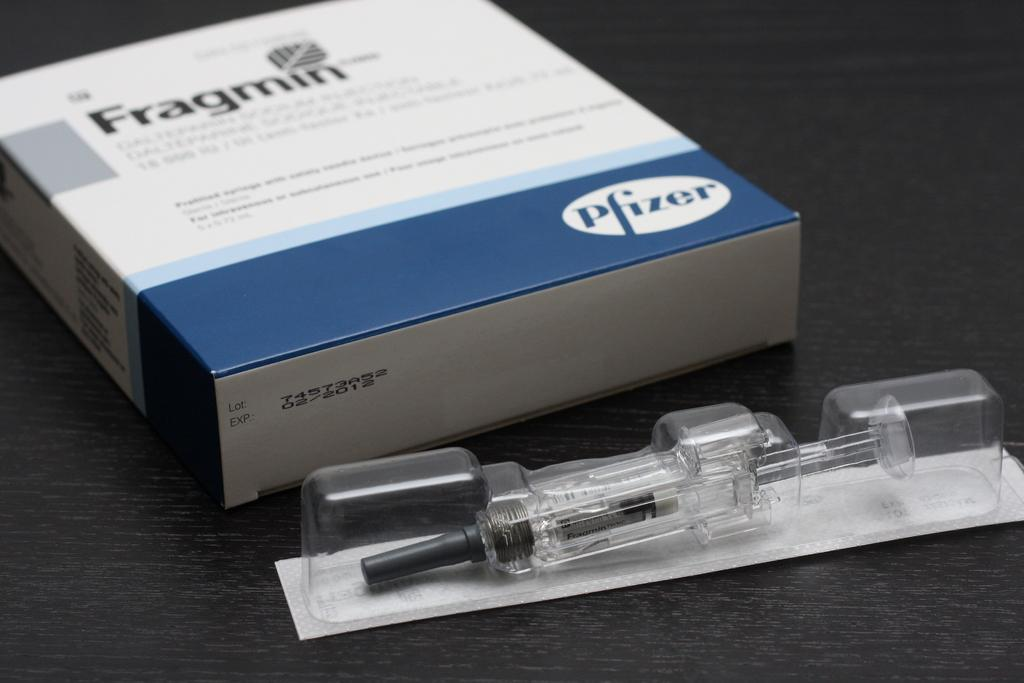<image>
Describe the image concisely. A box of Fragmin by Pfizer with the injection lying on a table outside of the box. 